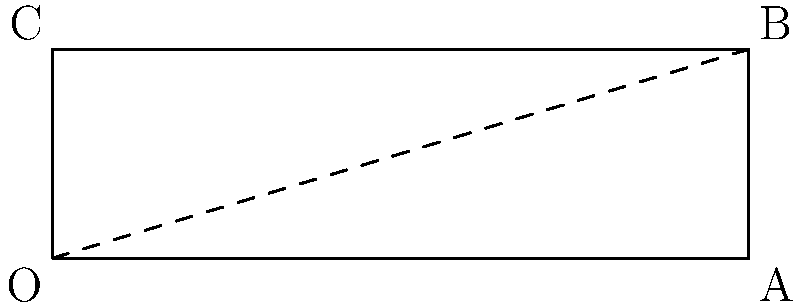During a crucial match in the Yemeni Premier League, you're tasked with taking a corner kick. The optimal spot to place the ball is at point B in the penalty area, which is 18 meters from the corner flag (point O) and 5.5 meters from the goal line. At what angle $\theta$ from the goal line should you aim to kick the ball for it to reach point B? To solve this problem, we can use basic trigonometry. Let's approach this step-by-step:

1) We have a right-angled triangle OAB, where:
   - OA is the goal line (18 meters)
   - AB is the distance from the goal line to point B (5.5 meters)
   - OB is the path of the ball (hypotenuse)

2) We need to find the angle $\theta$ at O.

3) We can use the arctangent (inverse tangent) function to find this angle:

   $\theta = \tan^{-1}(\frac{\text{opposite}}{\text{adjacent}})$

4) In this case:
   - The opposite side is AB (5.5 meters)
   - The adjacent side is OA (18 meters)

5) Plugging these values into our formula:

   $\theta = \tan^{-1}(\frac{5.5}{18})$

6) Using a calculator or computer:

   $\theta \approx 0.2966 \text{ radians}$

7) Converting to degrees:

   $\theta \approx 0.2966 \times \frac{180}{\pi} \approx 17.00^\circ$

Therefore, you should aim to kick the ball at approximately 17 degrees from the goal line to reach point B.
Answer: $17.00^\circ$ 